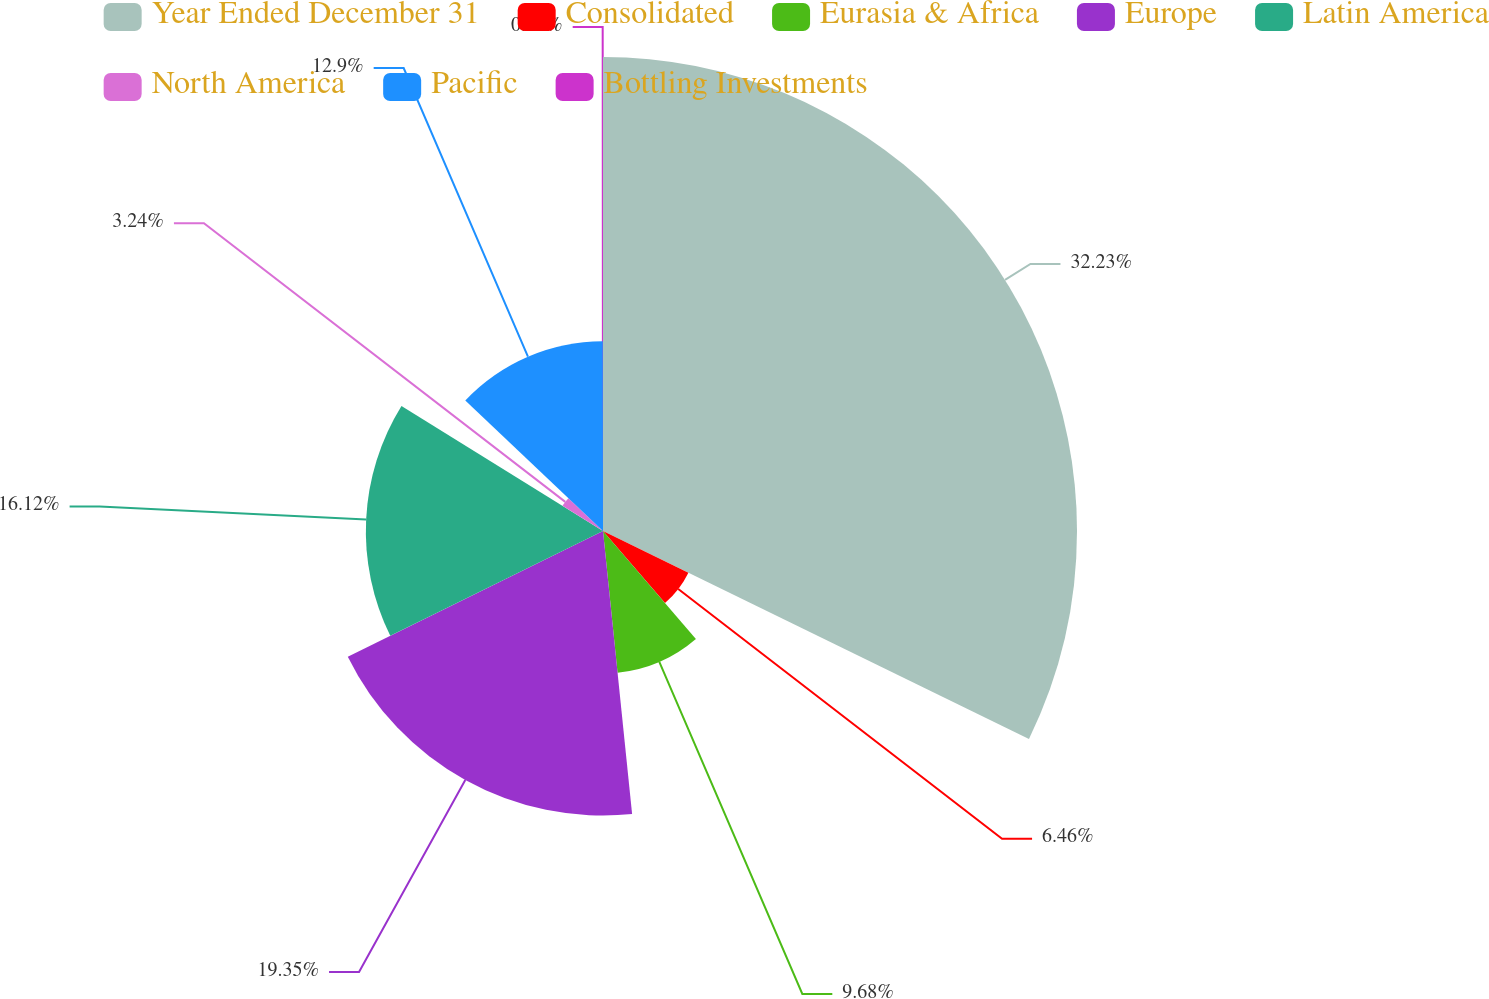<chart> <loc_0><loc_0><loc_500><loc_500><pie_chart><fcel>Year Ended December 31<fcel>Consolidated<fcel>Eurasia & Africa<fcel>Europe<fcel>Latin America<fcel>North America<fcel>Pacific<fcel>Bottling Investments<nl><fcel>32.22%<fcel>6.46%<fcel>9.68%<fcel>19.34%<fcel>16.12%<fcel>3.24%<fcel>12.9%<fcel>0.02%<nl></chart> 